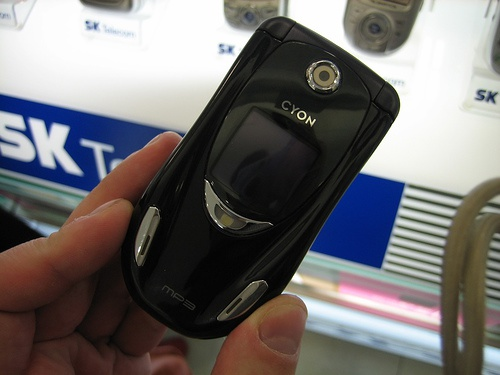Describe the objects in this image and their specific colors. I can see cell phone in darkgray, black, gray, and darkgreen tones, people in darkgray, black, maroon, and brown tones, and people in black and darkgray tones in this image. 